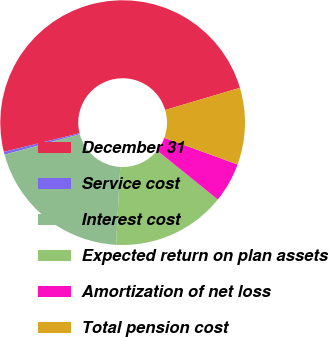<chart> <loc_0><loc_0><loc_500><loc_500><pie_chart><fcel>December 31<fcel>Service cost<fcel>Interest cost<fcel>Expected return on plan assets<fcel>Amortization of net loss<fcel>Total pension cost<nl><fcel>49.27%<fcel>0.37%<fcel>19.93%<fcel>15.04%<fcel>5.26%<fcel>10.15%<nl></chart> 